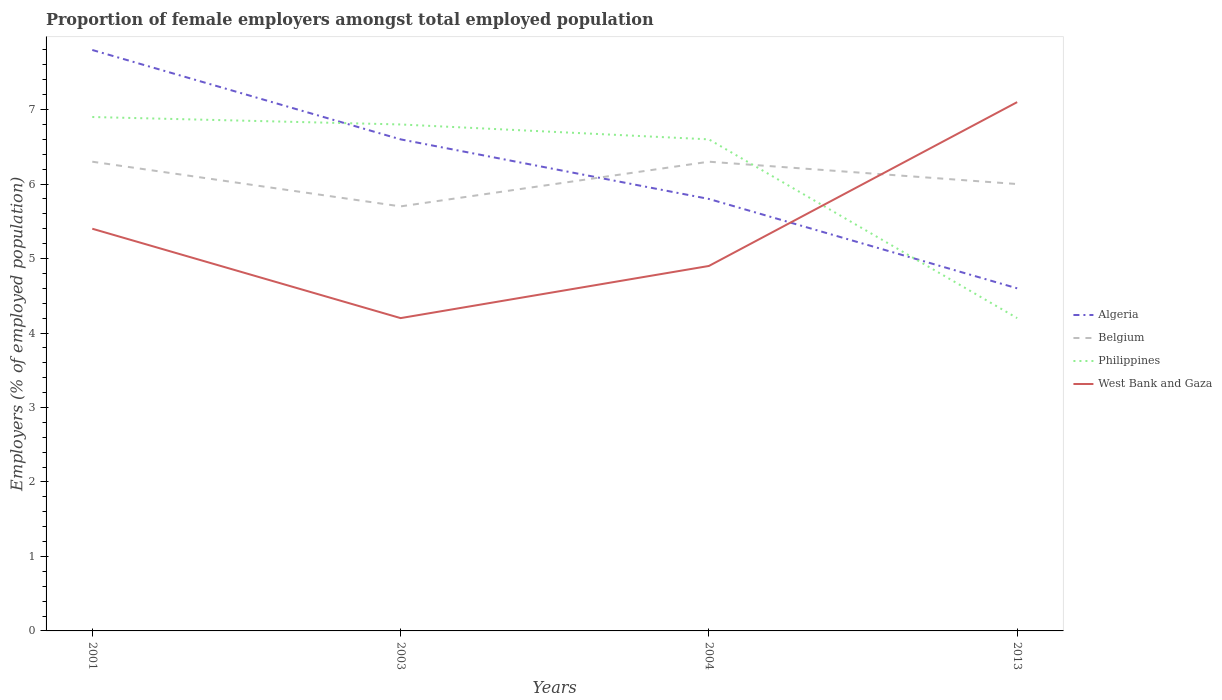Does the line corresponding to West Bank and Gaza intersect with the line corresponding to Belgium?
Make the answer very short. Yes. Is the number of lines equal to the number of legend labels?
Provide a short and direct response. Yes. Across all years, what is the maximum proportion of female employers in Philippines?
Your answer should be very brief. 4.2. In which year was the proportion of female employers in Algeria maximum?
Provide a succinct answer. 2013. What is the total proportion of female employers in West Bank and Gaza in the graph?
Your response must be concise. -2.9. What is the difference between the highest and the second highest proportion of female employers in Belgium?
Ensure brevity in your answer.  0.6. What is the difference between the highest and the lowest proportion of female employers in Belgium?
Your response must be concise. 2. Is the proportion of female employers in Belgium strictly greater than the proportion of female employers in Algeria over the years?
Offer a terse response. No. Where does the legend appear in the graph?
Your answer should be very brief. Center right. What is the title of the graph?
Provide a succinct answer. Proportion of female employers amongst total employed population. Does "Eritrea" appear as one of the legend labels in the graph?
Your response must be concise. No. What is the label or title of the X-axis?
Ensure brevity in your answer.  Years. What is the label or title of the Y-axis?
Your response must be concise. Employers (% of employed population). What is the Employers (% of employed population) in Algeria in 2001?
Offer a terse response. 7.8. What is the Employers (% of employed population) in Belgium in 2001?
Offer a very short reply. 6.3. What is the Employers (% of employed population) in Philippines in 2001?
Offer a very short reply. 6.9. What is the Employers (% of employed population) of West Bank and Gaza in 2001?
Provide a succinct answer. 5.4. What is the Employers (% of employed population) of Algeria in 2003?
Give a very brief answer. 6.6. What is the Employers (% of employed population) in Belgium in 2003?
Your answer should be very brief. 5.7. What is the Employers (% of employed population) in Philippines in 2003?
Provide a succinct answer. 6.8. What is the Employers (% of employed population) of West Bank and Gaza in 2003?
Provide a succinct answer. 4.2. What is the Employers (% of employed population) of Algeria in 2004?
Keep it short and to the point. 5.8. What is the Employers (% of employed population) of Belgium in 2004?
Give a very brief answer. 6.3. What is the Employers (% of employed population) of Philippines in 2004?
Your answer should be very brief. 6.6. What is the Employers (% of employed population) in West Bank and Gaza in 2004?
Offer a terse response. 4.9. What is the Employers (% of employed population) of Algeria in 2013?
Provide a short and direct response. 4.6. What is the Employers (% of employed population) in Belgium in 2013?
Offer a very short reply. 6. What is the Employers (% of employed population) in Philippines in 2013?
Give a very brief answer. 4.2. What is the Employers (% of employed population) in West Bank and Gaza in 2013?
Give a very brief answer. 7.1. Across all years, what is the maximum Employers (% of employed population) of Algeria?
Give a very brief answer. 7.8. Across all years, what is the maximum Employers (% of employed population) of Belgium?
Provide a succinct answer. 6.3. Across all years, what is the maximum Employers (% of employed population) in Philippines?
Give a very brief answer. 6.9. Across all years, what is the maximum Employers (% of employed population) of West Bank and Gaza?
Keep it short and to the point. 7.1. Across all years, what is the minimum Employers (% of employed population) in Algeria?
Provide a succinct answer. 4.6. Across all years, what is the minimum Employers (% of employed population) of Belgium?
Make the answer very short. 5.7. Across all years, what is the minimum Employers (% of employed population) of Philippines?
Ensure brevity in your answer.  4.2. Across all years, what is the minimum Employers (% of employed population) in West Bank and Gaza?
Your response must be concise. 4.2. What is the total Employers (% of employed population) in Algeria in the graph?
Your answer should be very brief. 24.8. What is the total Employers (% of employed population) in Belgium in the graph?
Your response must be concise. 24.3. What is the total Employers (% of employed population) in Philippines in the graph?
Your response must be concise. 24.5. What is the total Employers (% of employed population) of West Bank and Gaza in the graph?
Give a very brief answer. 21.6. What is the difference between the Employers (% of employed population) in Algeria in 2001 and that in 2003?
Offer a terse response. 1.2. What is the difference between the Employers (% of employed population) of Philippines in 2001 and that in 2003?
Provide a short and direct response. 0.1. What is the difference between the Employers (% of employed population) in West Bank and Gaza in 2001 and that in 2003?
Provide a succinct answer. 1.2. What is the difference between the Employers (% of employed population) in Algeria in 2001 and that in 2004?
Offer a terse response. 2. What is the difference between the Employers (% of employed population) of West Bank and Gaza in 2001 and that in 2004?
Provide a short and direct response. 0.5. What is the difference between the Employers (% of employed population) in Algeria in 2001 and that in 2013?
Your answer should be very brief. 3.2. What is the difference between the Employers (% of employed population) of West Bank and Gaza in 2001 and that in 2013?
Offer a terse response. -1.7. What is the difference between the Employers (% of employed population) in Algeria in 2003 and that in 2013?
Provide a succinct answer. 2. What is the difference between the Employers (% of employed population) of Philippines in 2003 and that in 2013?
Give a very brief answer. 2.6. What is the difference between the Employers (% of employed population) in West Bank and Gaza in 2003 and that in 2013?
Make the answer very short. -2.9. What is the difference between the Employers (% of employed population) of Belgium in 2004 and that in 2013?
Give a very brief answer. 0.3. What is the difference between the Employers (% of employed population) of Philippines in 2004 and that in 2013?
Ensure brevity in your answer.  2.4. What is the difference between the Employers (% of employed population) in Algeria in 2001 and the Employers (% of employed population) in Philippines in 2003?
Your answer should be compact. 1. What is the difference between the Employers (% of employed population) in Belgium in 2001 and the Employers (% of employed population) in Philippines in 2003?
Your answer should be compact. -0.5. What is the difference between the Employers (% of employed population) in Algeria in 2001 and the Employers (% of employed population) in Belgium in 2004?
Offer a terse response. 1.5. What is the difference between the Employers (% of employed population) in Philippines in 2001 and the Employers (% of employed population) in West Bank and Gaza in 2004?
Offer a terse response. 2. What is the difference between the Employers (% of employed population) in Algeria in 2001 and the Employers (% of employed population) in West Bank and Gaza in 2013?
Offer a terse response. 0.7. What is the difference between the Employers (% of employed population) in Algeria in 2003 and the Employers (% of employed population) in Belgium in 2004?
Your answer should be compact. 0.3. What is the difference between the Employers (% of employed population) in Algeria in 2003 and the Employers (% of employed population) in West Bank and Gaza in 2004?
Offer a very short reply. 1.7. What is the difference between the Employers (% of employed population) of Algeria in 2003 and the Employers (% of employed population) of Belgium in 2013?
Your answer should be compact. 0.6. What is the difference between the Employers (% of employed population) of Algeria in 2003 and the Employers (% of employed population) of West Bank and Gaza in 2013?
Keep it short and to the point. -0.5. What is the difference between the Employers (% of employed population) of Belgium in 2003 and the Employers (% of employed population) of West Bank and Gaza in 2013?
Your answer should be compact. -1.4. What is the difference between the Employers (% of employed population) in Algeria in 2004 and the Employers (% of employed population) in Belgium in 2013?
Give a very brief answer. -0.2. What is the difference between the Employers (% of employed population) of Algeria in 2004 and the Employers (% of employed population) of Philippines in 2013?
Your answer should be compact. 1.6. What is the difference between the Employers (% of employed population) in Belgium in 2004 and the Employers (% of employed population) in Philippines in 2013?
Your response must be concise. 2.1. What is the difference between the Employers (% of employed population) in Belgium in 2004 and the Employers (% of employed population) in West Bank and Gaza in 2013?
Your answer should be very brief. -0.8. What is the average Employers (% of employed population) of Belgium per year?
Offer a very short reply. 6.08. What is the average Employers (% of employed population) in Philippines per year?
Provide a short and direct response. 6.12. What is the average Employers (% of employed population) in West Bank and Gaza per year?
Your response must be concise. 5.4. In the year 2001, what is the difference between the Employers (% of employed population) in Algeria and Employers (% of employed population) in Belgium?
Keep it short and to the point. 1.5. In the year 2001, what is the difference between the Employers (% of employed population) of Algeria and Employers (% of employed population) of Philippines?
Your answer should be compact. 0.9. In the year 2001, what is the difference between the Employers (% of employed population) of Algeria and Employers (% of employed population) of West Bank and Gaza?
Your response must be concise. 2.4. In the year 2003, what is the difference between the Employers (% of employed population) of Algeria and Employers (% of employed population) of Belgium?
Offer a very short reply. 0.9. In the year 2003, what is the difference between the Employers (% of employed population) of Algeria and Employers (% of employed population) of West Bank and Gaza?
Your answer should be very brief. 2.4. In the year 2003, what is the difference between the Employers (% of employed population) of Belgium and Employers (% of employed population) of Philippines?
Your answer should be compact. -1.1. In the year 2004, what is the difference between the Employers (% of employed population) of Algeria and Employers (% of employed population) of Philippines?
Provide a succinct answer. -0.8. In the year 2004, what is the difference between the Employers (% of employed population) of Belgium and Employers (% of employed population) of Philippines?
Offer a very short reply. -0.3. In the year 2004, what is the difference between the Employers (% of employed population) in Philippines and Employers (% of employed population) in West Bank and Gaza?
Offer a terse response. 1.7. In the year 2013, what is the difference between the Employers (% of employed population) of Algeria and Employers (% of employed population) of Belgium?
Make the answer very short. -1.4. In the year 2013, what is the difference between the Employers (% of employed population) of Algeria and Employers (% of employed population) of Philippines?
Keep it short and to the point. 0.4. What is the ratio of the Employers (% of employed population) of Algeria in 2001 to that in 2003?
Give a very brief answer. 1.18. What is the ratio of the Employers (% of employed population) of Belgium in 2001 to that in 2003?
Offer a very short reply. 1.11. What is the ratio of the Employers (% of employed population) of Philippines in 2001 to that in 2003?
Provide a short and direct response. 1.01. What is the ratio of the Employers (% of employed population) in Algeria in 2001 to that in 2004?
Your answer should be very brief. 1.34. What is the ratio of the Employers (% of employed population) of Philippines in 2001 to that in 2004?
Give a very brief answer. 1.05. What is the ratio of the Employers (% of employed population) in West Bank and Gaza in 2001 to that in 2004?
Offer a terse response. 1.1. What is the ratio of the Employers (% of employed population) in Algeria in 2001 to that in 2013?
Offer a terse response. 1.7. What is the ratio of the Employers (% of employed population) in Belgium in 2001 to that in 2013?
Make the answer very short. 1.05. What is the ratio of the Employers (% of employed population) in Philippines in 2001 to that in 2013?
Your response must be concise. 1.64. What is the ratio of the Employers (% of employed population) of West Bank and Gaza in 2001 to that in 2013?
Offer a terse response. 0.76. What is the ratio of the Employers (% of employed population) in Algeria in 2003 to that in 2004?
Provide a short and direct response. 1.14. What is the ratio of the Employers (% of employed population) in Belgium in 2003 to that in 2004?
Offer a very short reply. 0.9. What is the ratio of the Employers (% of employed population) of Philippines in 2003 to that in 2004?
Offer a very short reply. 1.03. What is the ratio of the Employers (% of employed population) in West Bank and Gaza in 2003 to that in 2004?
Your answer should be compact. 0.86. What is the ratio of the Employers (% of employed population) of Algeria in 2003 to that in 2013?
Your answer should be very brief. 1.43. What is the ratio of the Employers (% of employed population) of Philippines in 2003 to that in 2013?
Offer a very short reply. 1.62. What is the ratio of the Employers (% of employed population) in West Bank and Gaza in 2003 to that in 2013?
Offer a terse response. 0.59. What is the ratio of the Employers (% of employed population) of Algeria in 2004 to that in 2013?
Offer a very short reply. 1.26. What is the ratio of the Employers (% of employed population) in Belgium in 2004 to that in 2013?
Your answer should be very brief. 1.05. What is the ratio of the Employers (% of employed population) of Philippines in 2004 to that in 2013?
Your answer should be very brief. 1.57. What is the ratio of the Employers (% of employed population) in West Bank and Gaza in 2004 to that in 2013?
Keep it short and to the point. 0.69. What is the difference between the highest and the second highest Employers (% of employed population) of Belgium?
Give a very brief answer. 0. What is the difference between the highest and the second highest Employers (% of employed population) in West Bank and Gaza?
Your response must be concise. 1.7. What is the difference between the highest and the lowest Employers (% of employed population) of Philippines?
Provide a succinct answer. 2.7. What is the difference between the highest and the lowest Employers (% of employed population) in West Bank and Gaza?
Ensure brevity in your answer.  2.9. 